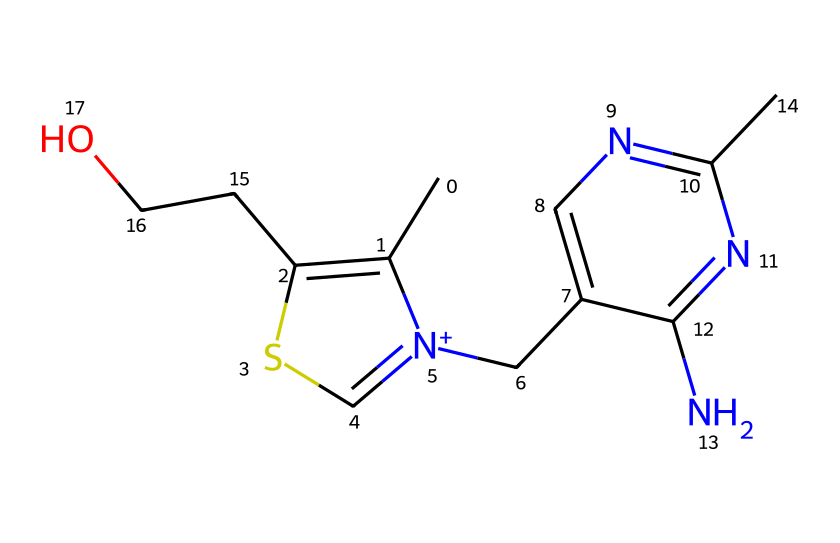What is the molecular formula of thiamine? To determine the molecular formula, I need to count the number of each type of atom present in the SMILES structure. The SMILES indicates carbon (C), hydrogen (H), nitrogen (N), oxygen (O), and sulfur (S). By interpreting the SMILES, I find there are 12 carbon atoms, 17 hydrogen atoms, 4 nitrogen atoms, 2 oxygen atoms, and 1 sulfur atom, leading to the molecular formula C12H17N4O2S.
Answer: C12H17N4O2S How many nitrogen atoms are found in thiamine? In analyzing the SMILES representation, I see that there are specific parts where nitrogen atoms are identified, specifically marked by "N". Counting these occurrences in the structure, I find there are 4 nitrogen atoms.
Answer: 4 What type of bond is present between the sulfur and the carbon in thiamine? Observing the structure derived from the SMILES, I note that the sulfur (S) is bonded to a carbon (C) through a single bond indicated by the connectivity. This bond contributes to the larger structure as a thiol or thioether connection with other components.
Answer: single bond What is the role of sulfur in thiamine? Understanding the role of sulfur in this compound requires me to consider the general properties of vitamins and their biological relevance. Sulfur is crucial for maintaining enzyme activity, affecting growth and development, and in thiamine specifically, it contributes to the stabilization of the overall molecular structure.
Answer: stabilization Which part of thiamine contributes to its classification as a vitamin? In order to classify thiamine as a vitamin, I need to look for the functional groups or characteristics typical of vitamins. The presence of the heterocyclic ring combined with multiple nitrogen atoms is essential for activity. The ring structure, along with its interactions in metabolism, confirms its status as a vitamin.
Answer: heterocyclic ring 